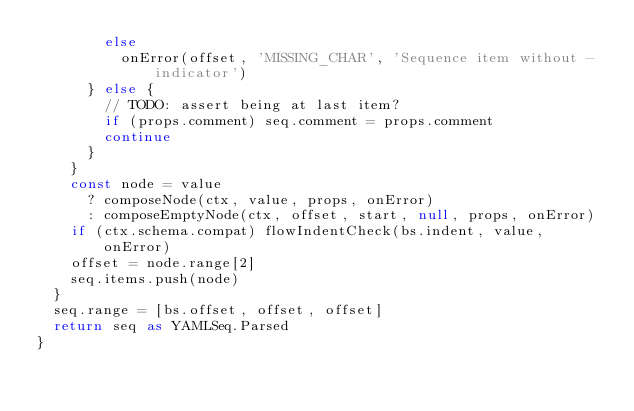Convert code to text. <code><loc_0><loc_0><loc_500><loc_500><_TypeScript_>        else
          onError(offset, 'MISSING_CHAR', 'Sequence item without - indicator')
      } else {
        // TODO: assert being at last item?
        if (props.comment) seq.comment = props.comment
        continue
      }
    }
    const node = value
      ? composeNode(ctx, value, props, onError)
      : composeEmptyNode(ctx, offset, start, null, props, onError)
    if (ctx.schema.compat) flowIndentCheck(bs.indent, value, onError)
    offset = node.range[2]
    seq.items.push(node)
  }
  seq.range = [bs.offset, offset, offset]
  return seq as YAMLSeq.Parsed
}
</code> 